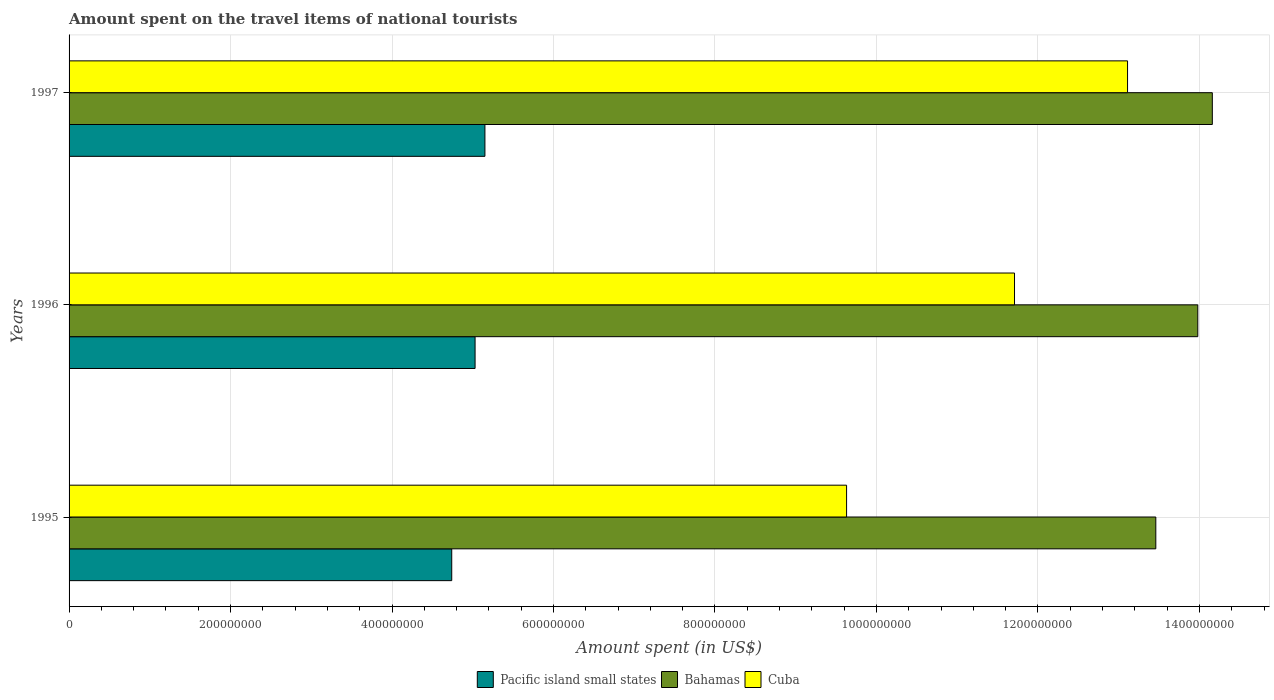How many groups of bars are there?
Provide a short and direct response. 3. How many bars are there on the 2nd tick from the top?
Give a very brief answer. 3. What is the label of the 1st group of bars from the top?
Ensure brevity in your answer.  1997. In how many cases, is the number of bars for a given year not equal to the number of legend labels?
Give a very brief answer. 0. What is the amount spent on the travel items of national tourists in Pacific island small states in 1995?
Ensure brevity in your answer.  4.74e+08. Across all years, what is the maximum amount spent on the travel items of national tourists in Pacific island small states?
Provide a succinct answer. 5.15e+08. Across all years, what is the minimum amount spent on the travel items of national tourists in Cuba?
Your response must be concise. 9.63e+08. In which year was the amount spent on the travel items of national tourists in Cuba minimum?
Give a very brief answer. 1995. What is the total amount spent on the travel items of national tourists in Pacific island small states in the graph?
Give a very brief answer. 1.49e+09. What is the difference between the amount spent on the travel items of national tourists in Bahamas in 1995 and that in 1996?
Your response must be concise. -5.20e+07. What is the difference between the amount spent on the travel items of national tourists in Cuba in 1996 and the amount spent on the travel items of national tourists in Bahamas in 1995?
Give a very brief answer. -1.75e+08. What is the average amount spent on the travel items of national tourists in Pacific island small states per year?
Your response must be concise. 4.97e+08. In the year 1997, what is the difference between the amount spent on the travel items of national tourists in Bahamas and amount spent on the travel items of national tourists in Cuba?
Give a very brief answer. 1.05e+08. In how many years, is the amount spent on the travel items of national tourists in Cuba greater than 80000000 US$?
Make the answer very short. 3. What is the ratio of the amount spent on the travel items of national tourists in Bahamas in 1996 to that in 1997?
Give a very brief answer. 0.99. Is the amount spent on the travel items of national tourists in Cuba in 1996 less than that in 1997?
Provide a short and direct response. Yes. What is the difference between the highest and the second highest amount spent on the travel items of national tourists in Bahamas?
Your answer should be compact. 1.80e+07. What is the difference between the highest and the lowest amount spent on the travel items of national tourists in Cuba?
Make the answer very short. 3.48e+08. What does the 3rd bar from the top in 1995 represents?
Offer a terse response. Pacific island small states. What does the 2nd bar from the bottom in 1996 represents?
Provide a short and direct response. Bahamas. Is it the case that in every year, the sum of the amount spent on the travel items of national tourists in Pacific island small states and amount spent on the travel items of national tourists in Bahamas is greater than the amount spent on the travel items of national tourists in Cuba?
Your response must be concise. Yes. Are all the bars in the graph horizontal?
Offer a terse response. Yes. Are the values on the major ticks of X-axis written in scientific E-notation?
Your answer should be very brief. No. Does the graph contain any zero values?
Provide a short and direct response. No. How many legend labels are there?
Offer a very short reply. 3. How are the legend labels stacked?
Provide a short and direct response. Horizontal. What is the title of the graph?
Provide a short and direct response. Amount spent on the travel items of national tourists. Does "Honduras" appear as one of the legend labels in the graph?
Ensure brevity in your answer.  No. What is the label or title of the X-axis?
Offer a very short reply. Amount spent (in US$). What is the Amount spent (in US$) in Pacific island small states in 1995?
Ensure brevity in your answer.  4.74e+08. What is the Amount spent (in US$) of Bahamas in 1995?
Provide a succinct answer. 1.35e+09. What is the Amount spent (in US$) of Cuba in 1995?
Give a very brief answer. 9.63e+08. What is the Amount spent (in US$) of Pacific island small states in 1996?
Your response must be concise. 5.03e+08. What is the Amount spent (in US$) of Bahamas in 1996?
Ensure brevity in your answer.  1.40e+09. What is the Amount spent (in US$) of Cuba in 1996?
Ensure brevity in your answer.  1.17e+09. What is the Amount spent (in US$) of Pacific island small states in 1997?
Ensure brevity in your answer.  5.15e+08. What is the Amount spent (in US$) in Bahamas in 1997?
Provide a short and direct response. 1.42e+09. What is the Amount spent (in US$) in Cuba in 1997?
Give a very brief answer. 1.31e+09. Across all years, what is the maximum Amount spent (in US$) in Pacific island small states?
Your answer should be very brief. 5.15e+08. Across all years, what is the maximum Amount spent (in US$) of Bahamas?
Give a very brief answer. 1.42e+09. Across all years, what is the maximum Amount spent (in US$) in Cuba?
Provide a succinct answer. 1.31e+09. Across all years, what is the minimum Amount spent (in US$) of Pacific island small states?
Provide a succinct answer. 4.74e+08. Across all years, what is the minimum Amount spent (in US$) of Bahamas?
Keep it short and to the point. 1.35e+09. Across all years, what is the minimum Amount spent (in US$) in Cuba?
Keep it short and to the point. 9.63e+08. What is the total Amount spent (in US$) of Pacific island small states in the graph?
Your answer should be compact. 1.49e+09. What is the total Amount spent (in US$) of Bahamas in the graph?
Make the answer very short. 4.16e+09. What is the total Amount spent (in US$) in Cuba in the graph?
Offer a very short reply. 3.44e+09. What is the difference between the Amount spent (in US$) in Pacific island small states in 1995 and that in 1996?
Ensure brevity in your answer.  -2.89e+07. What is the difference between the Amount spent (in US$) in Bahamas in 1995 and that in 1996?
Your answer should be compact. -5.20e+07. What is the difference between the Amount spent (in US$) of Cuba in 1995 and that in 1996?
Give a very brief answer. -2.08e+08. What is the difference between the Amount spent (in US$) of Pacific island small states in 1995 and that in 1997?
Keep it short and to the point. -4.11e+07. What is the difference between the Amount spent (in US$) in Bahamas in 1995 and that in 1997?
Your response must be concise. -7.00e+07. What is the difference between the Amount spent (in US$) of Cuba in 1995 and that in 1997?
Your answer should be compact. -3.48e+08. What is the difference between the Amount spent (in US$) of Pacific island small states in 1996 and that in 1997?
Keep it short and to the point. -1.22e+07. What is the difference between the Amount spent (in US$) of Bahamas in 1996 and that in 1997?
Your answer should be very brief. -1.80e+07. What is the difference between the Amount spent (in US$) of Cuba in 1996 and that in 1997?
Provide a short and direct response. -1.40e+08. What is the difference between the Amount spent (in US$) in Pacific island small states in 1995 and the Amount spent (in US$) in Bahamas in 1996?
Offer a very short reply. -9.24e+08. What is the difference between the Amount spent (in US$) in Pacific island small states in 1995 and the Amount spent (in US$) in Cuba in 1996?
Keep it short and to the point. -6.97e+08. What is the difference between the Amount spent (in US$) in Bahamas in 1995 and the Amount spent (in US$) in Cuba in 1996?
Offer a terse response. 1.75e+08. What is the difference between the Amount spent (in US$) of Pacific island small states in 1995 and the Amount spent (in US$) of Bahamas in 1997?
Provide a short and direct response. -9.42e+08. What is the difference between the Amount spent (in US$) of Pacific island small states in 1995 and the Amount spent (in US$) of Cuba in 1997?
Provide a succinct answer. -8.37e+08. What is the difference between the Amount spent (in US$) of Bahamas in 1995 and the Amount spent (in US$) of Cuba in 1997?
Provide a succinct answer. 3.50e+07. What is the difference between the Amount spent (in US$) in Pacific island small states in 1996 and the Amount spent (in US$) in Bahamas in 1997?
Ensure brevity in your answer.  -9.13e+08. What is the difference between the Amount spent (in US$) in Pacific island small states in 1996 and the Amount spent (in US$) in Cuba in 1997?
Your answer should be compact. -8.08e+08. What is the difference between the Amount spent (in US$) of Bahamas in 1996 and the Amount spent (in US$) of Cuba in 1997?
Provide a succinct answer. 8.70e+07. What is the average Amount spent (in US$) of Pacific island small states per year?
Your answer should be very brief. 4.97e+08. What is the average Amount spent (in US$) of Bahamas per year?
Your answer should be compact. 1.39e+09. What is the average Amount spent (in US$) in Cuba per year?
Make the answer very short. 1.15e+09. In the year 1995, what is the difference between the Amount spent (in US$) of Pacific island small states and Amount spent (in US$) of Bahamas?
Make the answer very short. -8.72e+08. In the year 1995, what is the difference between the Amount spent (in US$) of Pacific island small states and Amount spent (in US$) of Cuba?
Offer a very short reply. -4.89e+08. In the year 1995, what is the difference between the Amount spent (in US$) of Bahamas and Amount spent (in US$) of Cuba?
Make the answer very short. 3.83e+08. In the year 1996, what is the difference between the Amount spent (in US$) of Pacific island small states and Amount spent (in US$) of Bahamas?
Provide a succinct answer. -8.95e+08. In the year 1996, what is the difference between the Amount spent (in US$) of Pacific island small states and Amount spent (in US$) of Cuba?
Make the answer very short. -6.68e+08. In the year 1996, what is the difference between the Amount spent (in US$) of Bahamas and Amount spent (in US$) of Cuba?
Your answer should be very brief. 2.27e+08. In the year 1997, what is the difference between the Amount spent (in US$) in Pacific island small states and Amount spent (in US$) in Bahamas?
Provide a short and direct response. -9.01e+08. In the year 1997, what is the difference between the Amount spent (in US$) of Pacific island small states and Amount spent (in US$) of Cuba?
Provide a succinct answer. -7.96e+08. In the year 1997, what is the difference between the Amount spent (in US$) in Bahamas and Amount spent (in US$) in Cuba?
Your answer should be compact. 1.05e+08. What is the ratio of the Amount spent (in US$) of Pacific island small states in 1995 to that in 1996?
Offer a terse response. 0.94. What is the ratio of the Amount spent (in US$) of Bahamas in 1995 to that in 1996?
Your answer should be compact. 0.96. What is the ratio of the Amount spent (in US$) in Cuba in 1995 to that in 1996?
Provide a short and direct response. 0.82. What is the ratio of the Amount spent (in US$) in Pacific island small states in 1995 to that in 1997?
Make the answer very short. 0.92. What is the ratio of the Amount spent (in US$) in Bahamas in 1995 to that in 1997?
Offer a terse response. 0.95. What is the ratio of the Amount spent (in US$) in Cuba in 1995 to that in 1997?
Your answer should be very brief. 0.73. What is the ratio of the Amount spent (in US$) in Pacific island small states in 1996 to that in 1997?
Provide a succinct answer. 0.98. What is the ratio of the Amount spent (in US$) in Bahamas in 1996 to that in 1997?
Provide a short and direct response. 0.99. What is the ratio of the Amount spent (in US$) of Cuba in 1996 to that in 1997?
Keep it short and to the point. 0.89. What is the difference between the highest and the second highest Amount spent (in US$) of Pacific island small states?
Your response must be concise. 1.22e+07. What is the difference between the highest and the second highest Amount spent (in US$) in Bahamas?
Keep it short and to the point. 1.80e+07. What is the difference between the highest and the second highest Amount spent (in US$) of Cuba?
Your answer should be very brief. 1.40e+08. What is the difference between the highest and the lowest Amount spent (in US$) of Pacific island small states?
Keep it short and to the point. 4.11e+07. What is the difference between the highest and the lowest Amount spent (in US$) of Bahamas?
Keep it short and to the point. 7.00e+07. What is the difference between the highest and the lowest Amount spent (in US$) of Cuba?
Your response must be concise. 3.48e+08. 